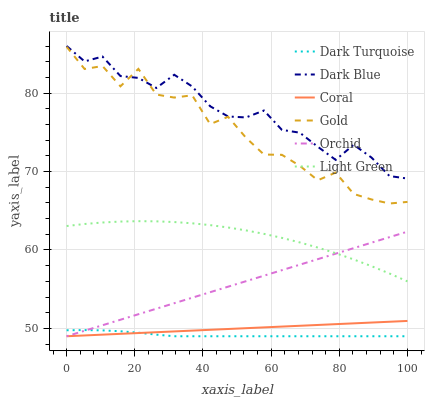Does Coral have the minimum area under the curve?
Answer yes or no. No. Does Coral have the maximum area under the curve?
Answer yes or no. No. Is Dark Turquoise the smoothest?
Answer yes or no. No. Is Dark Turquoise the roughest?
Answer yes or no. No. Does Dark Blue have the lowest value?
Answer yes or no. No. Does Coral have the highest value?
Answer yes or no. No. Is Light Green less than Dark Blue?
Answer yes or no. Yes. Is Gold greater than Orchid?
Answer yes or no. Yes. Does Light Green intersect Dark Blue?
Answer yes or no. No. 